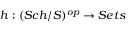<formula> <loc_0><loc_0><loc_500><loc_500>h \colon ( S c h / S ) ^ { o p } \to S e t s</formula> 